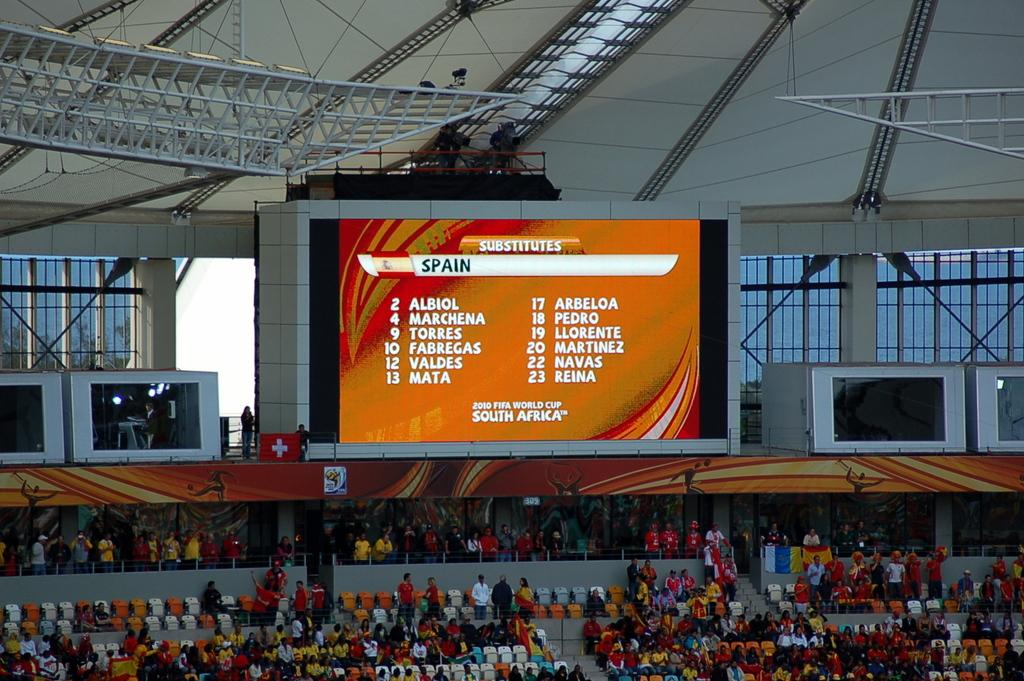What is the main object in the image? There is a screen in the image. What can be seen on the screen? Something is written on the screen. Who or what is visible in the image? There are people visible in the image. What type of furniture is present in the image? There are chairs in the image. What type of cracker is being used to clean the screen in the image? There is no cracker present in the image, and the screen is not being cleaned. 